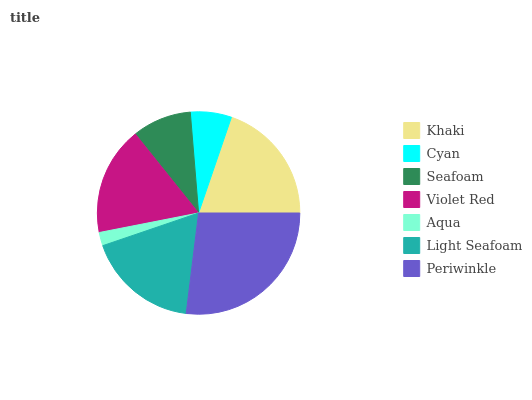Is Aqua the minimum?
Answer yes or no. Yes. Is Periwinkle the maximum?
Answer yes or no. Yes. Is Cyan the minimum?
Answer yes or no. No. Is Cyan the maximum?
Answer yes or no. No. Is Khaki greater than Cyan?
Answer yes or no. Yes. Is Cyan less than Khaki?
Answer yes or no. Yes. Is Cyan greater than Khaki?
Answer yes or no. No. Is Khaki less than Cyan?
Answer yes or no. No. Is Violet Red the high median?
Answer yes or no. Yes. Is Violet Red the low median?
Answer yes or no. Yes. Is Khaki the high median?
Answer yes or no. No. Is Seafoam the low median?
Answer yes or no. No. 